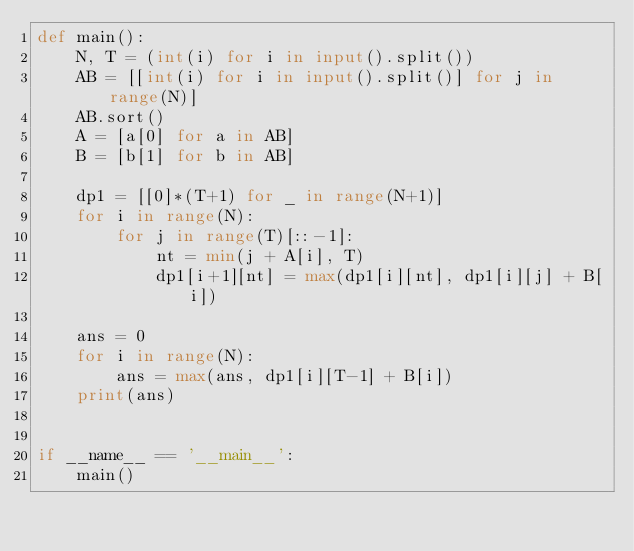Convert code to text. <code><loc_0><loc_0><loc_500><loc_500><_Python_>def main():
    N, T = (int(i) for i in input().split())
    AB = [[int(i) for i in input().split()] for j in range(N)]
    AB.sort()
    A = [a[0] for a in AB]
    B = [b[1] for b in AB]

    dp1 = [[0]*(T+1) for _ in range(N+1)]
    for i in range(N):
        for j in range(T)[::-1]:
            nt = min(j + A[i], T)
            dp1[i+1][nt] = max(dp1[i][nt], dp1[i][j] + B[i])

    ans = 0
    for i in range(N):
        ans = max(ans, dp1[i][T-1] + B[i])
    print(ans)


if __name__ == '__main__':
    main()
</code> 